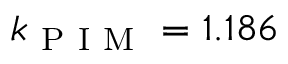<formula> <loc_0><loc_0><loc_500><loc_500>k _ { P I M } = 1 . 1 8 6</formula> 